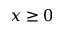<formula> <loc_0><loc_0><loc_500><loc_500>x \geq 0</formula> 